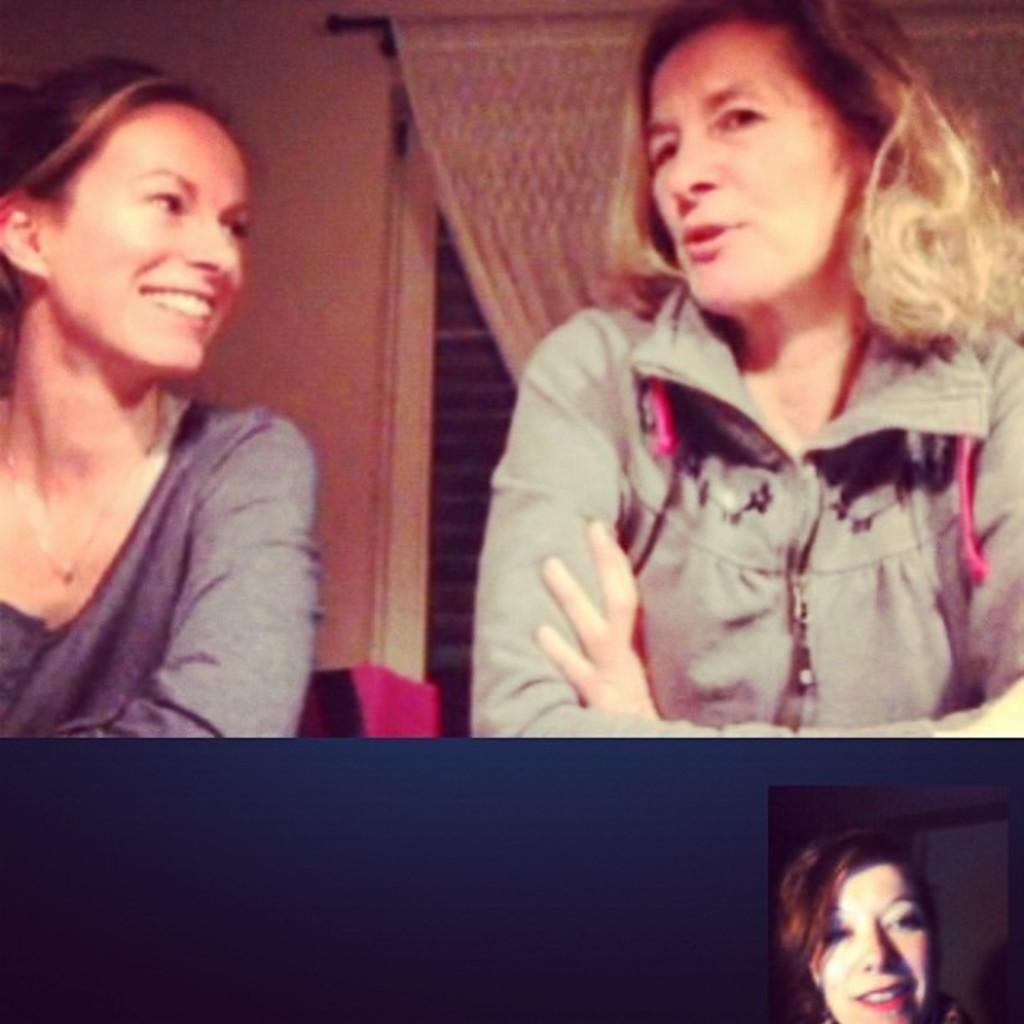How many people are in the image? There are two women in the image. What is the facial expression of one of the women? One of the women is smiling. What type of clothing is one of the women wearing? One of the women is wearing a jacket. Can you see the faces of the women in the image? Yes, the faces of the women are visible in the image. What type of mask is the woman wearing in the image? There is no mask present in the image; both women's faces are visible. 